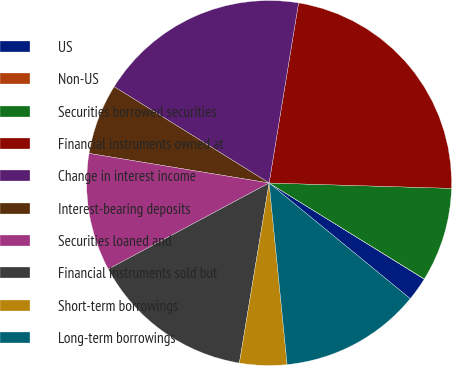<chart> <loc_0><loc_0><loc_500><loc_500><pie_chart><fcel>US<fcel>Non-US<fcel>Securities borrowed securities<fcel>Financial instruments owned at<fcel>Change in interest income<fcel>Interest-bearing deposits<fcel>Securities loaned and<fcel>Financial instruments sold but<fcel>Short-term borrowings<fcel>Long-term borrowings<nl><fcel>2.1%<fcel>0.02%<fcel>8.34%<fcel>22.89%<fcel>18.73%<fcel>6.26%<fcel>10.42%<fcel>14.57%<fcel>4.18%<fcel>12.5%<nl></chart> 